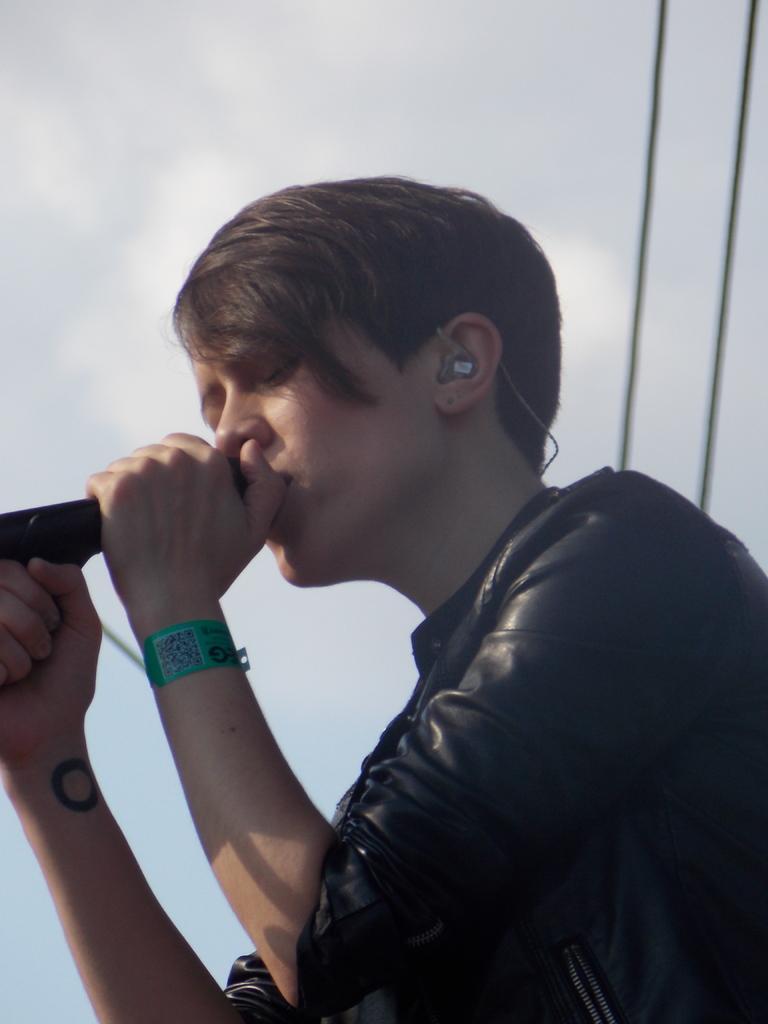In one or two sentences, can you explain what this image depicts? In this image there is a man holding the mike in his hand, in the background there is the sky and wires. 